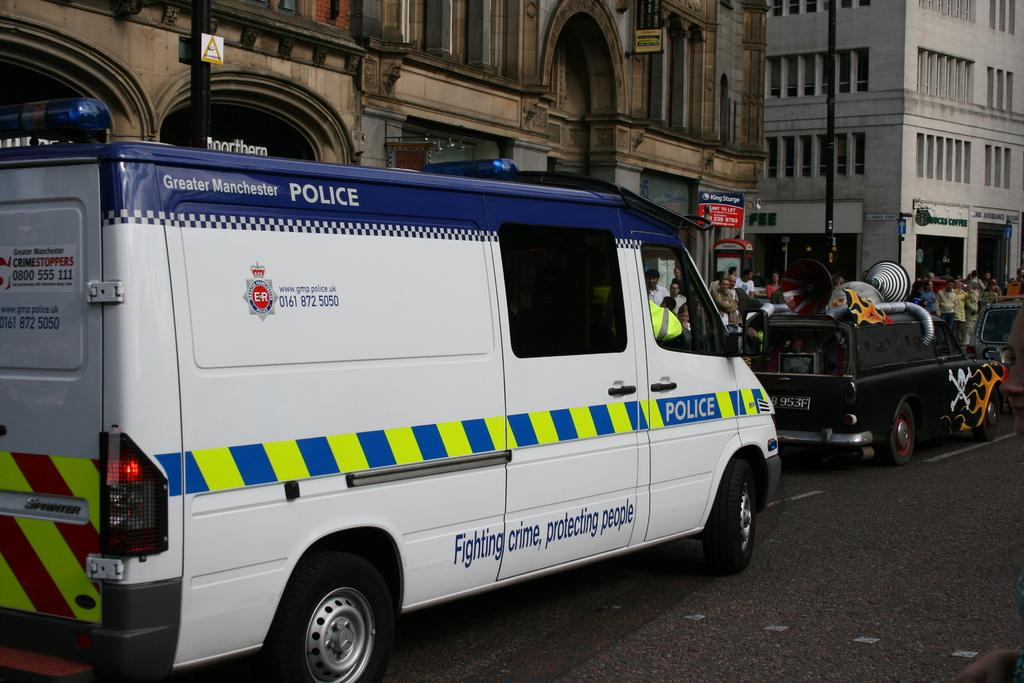What can be seen on the road in the image? There are vehicles on the road in the image. What is visible in the background of the image? There are buildings, signboards, poles, people, and windows visible in the background. Where is the hydrant located in the image? There is no hydrant present in the image. How many sheep can be seen in the image? There are no sheep present in the image. 